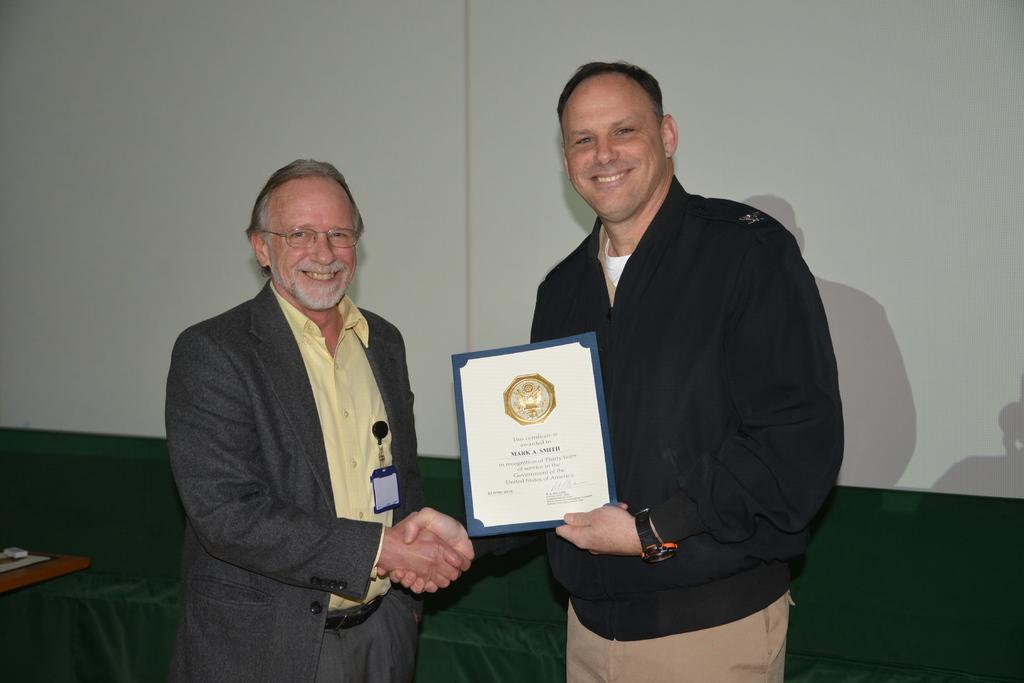Please provide a concise description of this image. In the center of the image there are two persons shaking hands. In the background of the image there is wall. There is a green color sofa. To the left side of the image there is a table. 